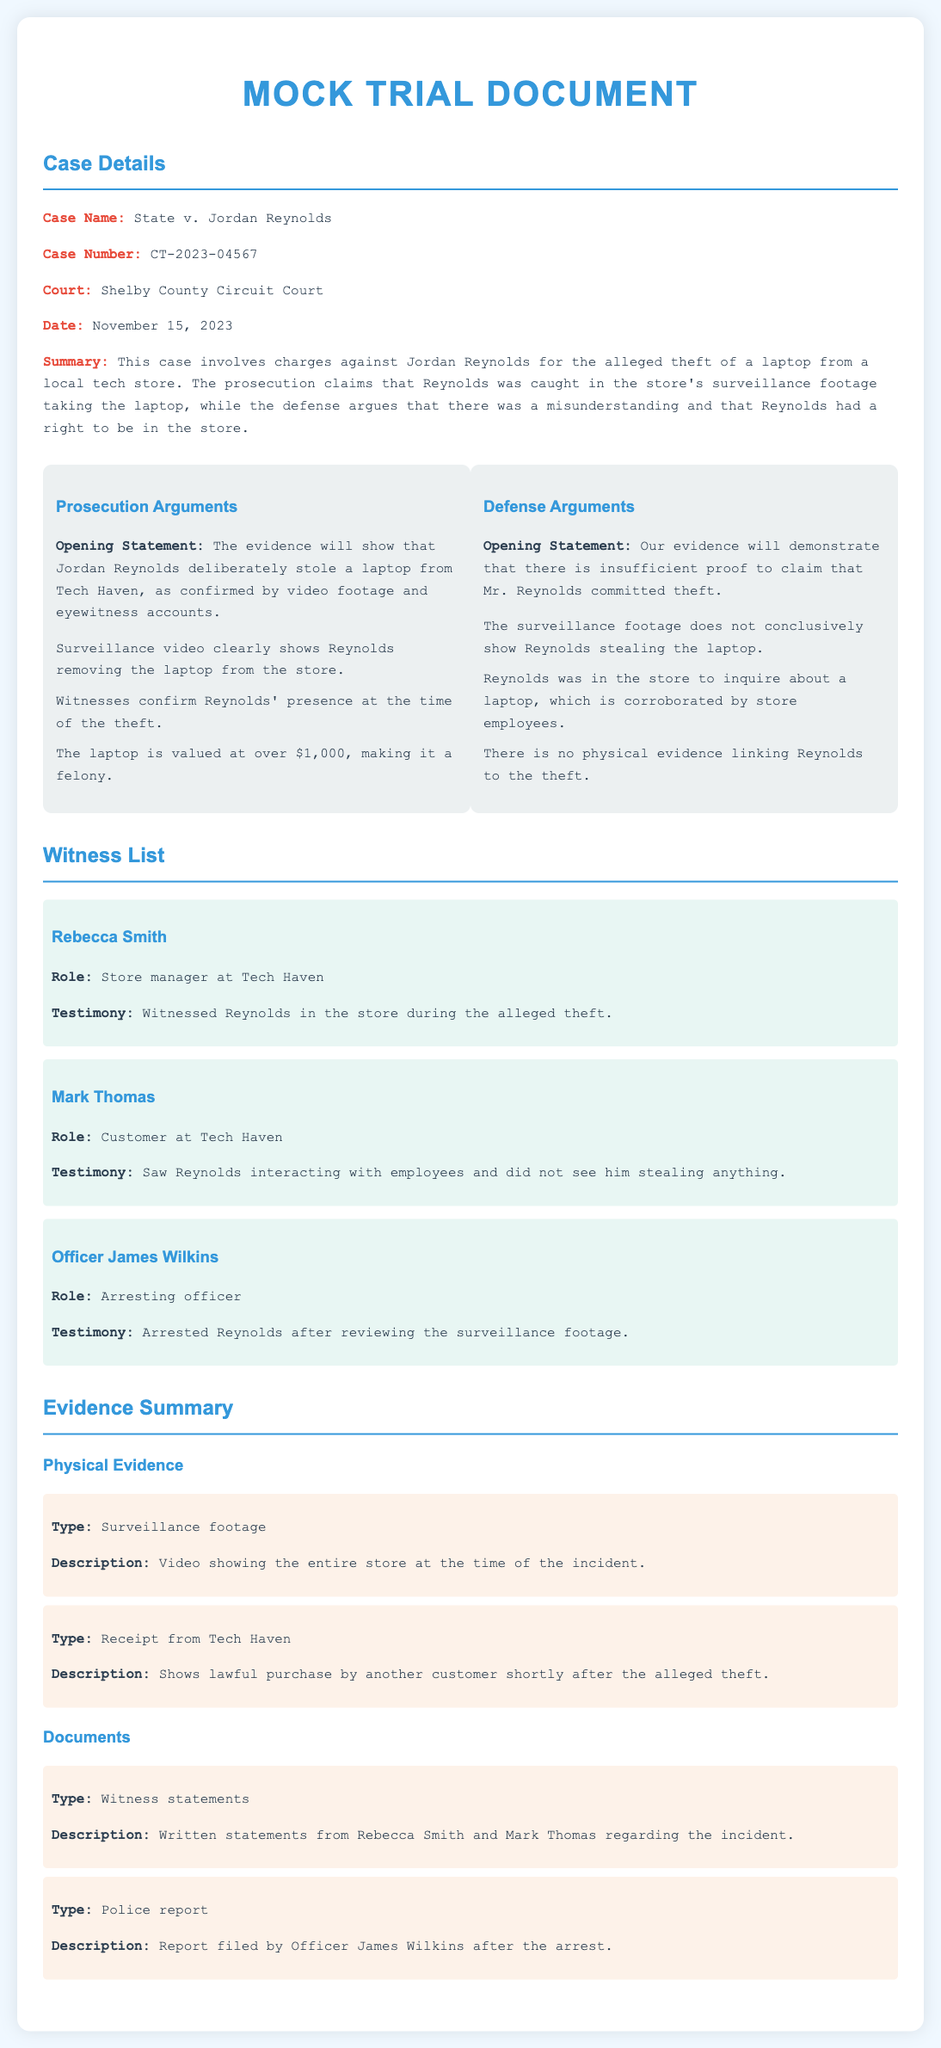What is the case name? The case name is provided in the case details section of the document.
Answer: State v. Jordan Reynolds What is the date of the trial? The document specifies the date under the case details section.
Answer: November 15, 2023 Who is the defendant in the case? The document lists the defendant's name in the case details section.
Answer: Jordan Reynolds What is the primary evidence against Reynolds? This information can be found in the prosecution's arguments section regarding the evidence presented.
Answer: Surveillance video What is the value of the laptop stolen? The value is mentioned in the prosecution's arguments indicating the severity of the crime.
Answer: Over $1,000 What did Mark Thomas witness? This question focuses on the testimony of a specific witness listed in the document.
Answer: Reynolds interacting with employees What is the role of Officer James Wilkins? The document specifies each witness's role in the witness list section.
Answer: Arresting officer What type of evidence includes a report filed by the officer? This question references the section describing the types of evidence summarized in the document.
Answer: Documents What does the defense argue about the surveillance footage? The argument from the defense provides insights into their reasoning presented in the document.
Answer: Does not conclusively show Reynolds stealing the laptop 